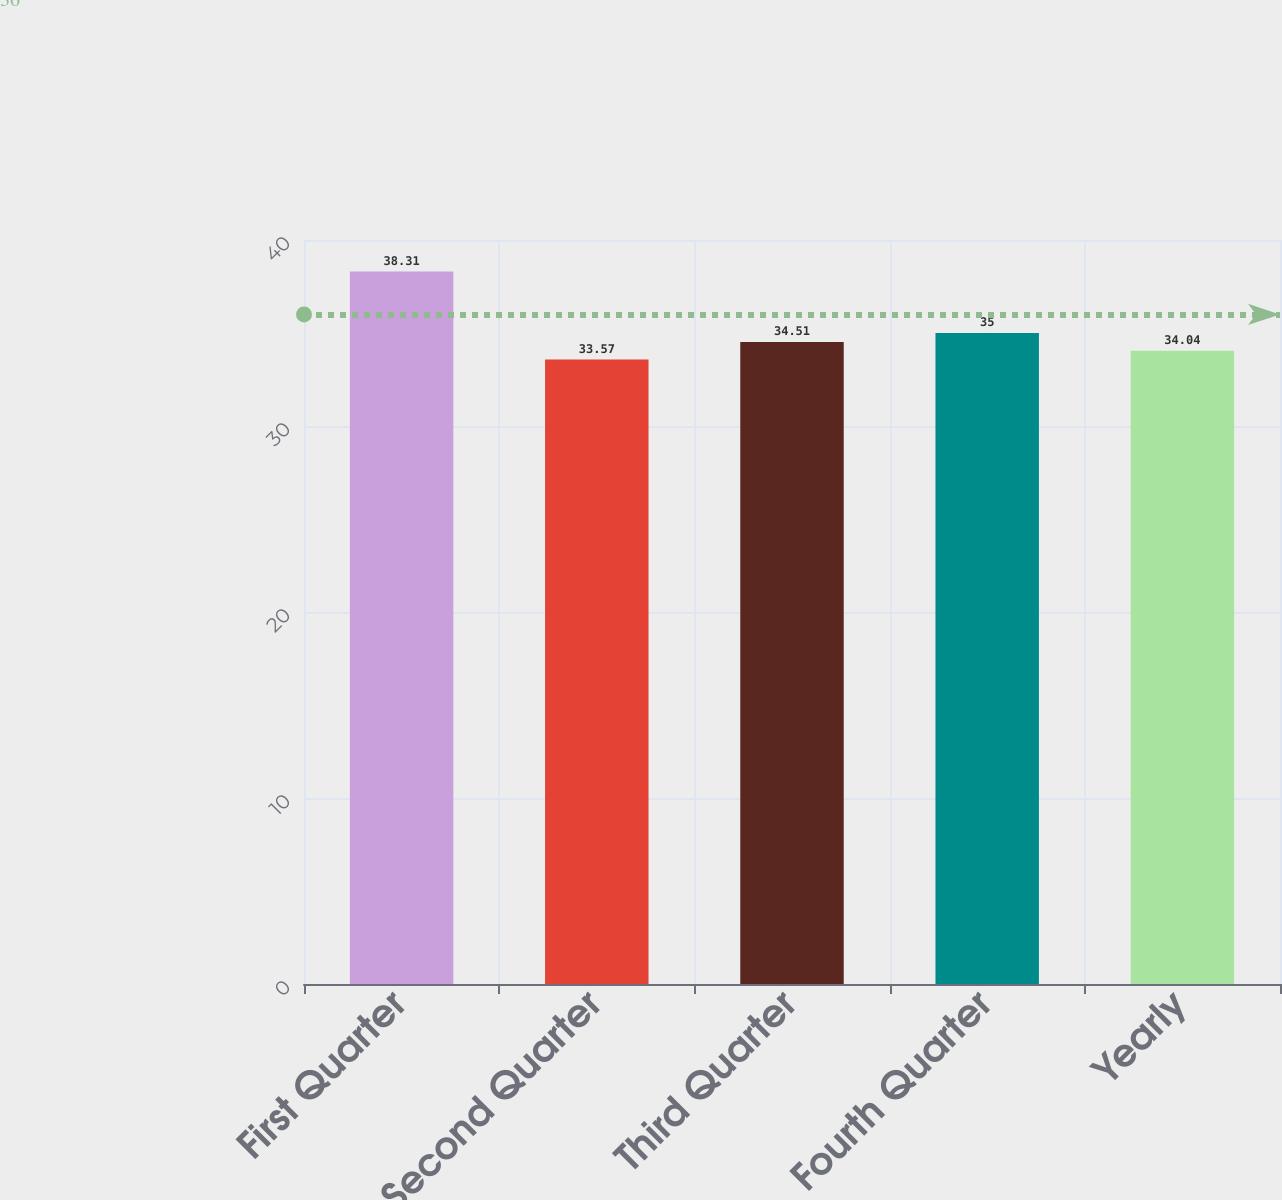Convert chart to OTSL. <chart><loc_0><loc_0><loc_500><loc_500><bar_chart><fcel>First Quarter<fcel>Second Quarter<fcel>Third Quarter<fcel>Fourth Quarter<fcel>Yearly<nl><fcel>38.31<fcel>33.57<fcel>34.51<fcel>35<fcel>34.04<nl></chart> 